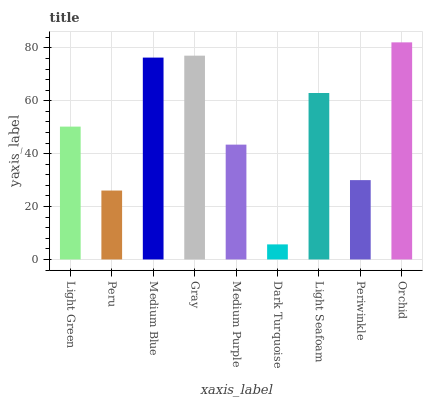Is Dark Turquoise the minimum?
Answer yes or no. Yes. Is Orchid the maximum?
Answer yes or no. Yes. Is Peru the minimum?
Answer yes or no. No. Is Peru the maximum?
Answer yes or no. No. Is Light Green greater than Peru?
Answer yes or no. Yes. Is Peru less than Light Green?
Answer yes or no. Yes. Is Peru greater than Light Green?
Answer yes or no. No. Is Light Green less than Peru?
Answer yes or no. No. Is Light Green the high median?
Answer yes or no. Yes. Is Light Green the low median?
Answer yes or no. Yes. Is Medium Purple the high median?
Answer yes or no. No. Is Medium Blue the low median?
Answer yes or no. No. 